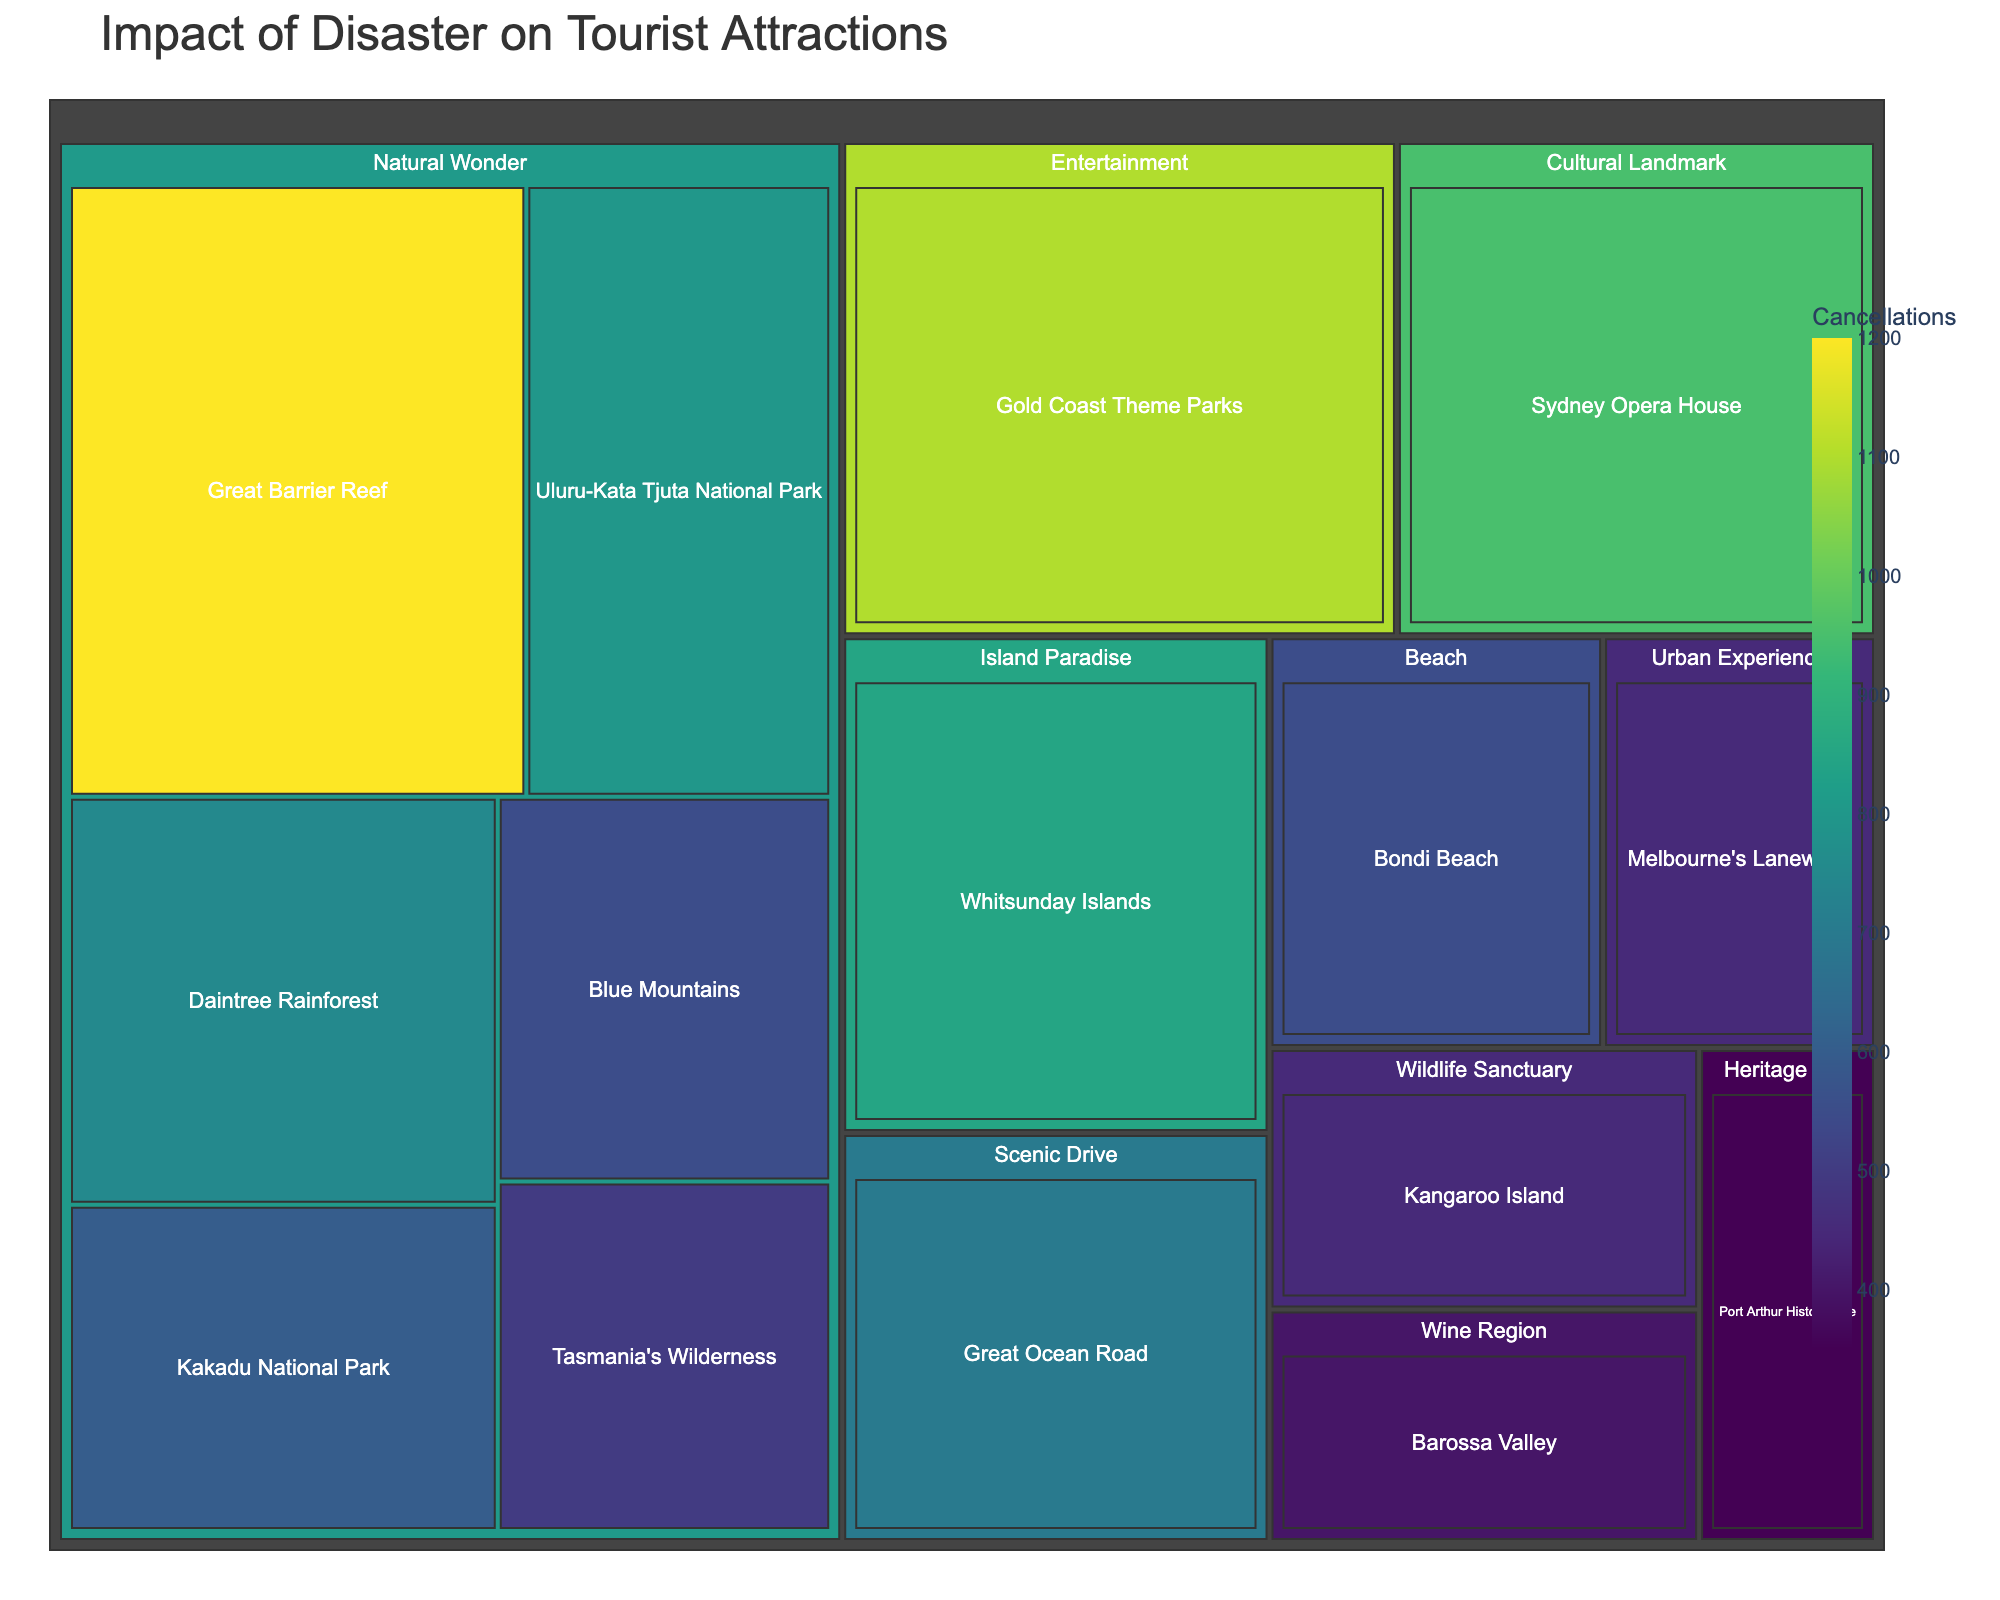What is the total number of cancellations across all tourist attractions? The treemap shows the number of cancellations for each attraction. To find the total, we sum all these values: 1200 + 800 + 950 + 1100 + 600 + 450 + 750 + 550 + 500 + 700 + 400 + 850 + 550 + 450 + 350.
Answer: 10200 Which tourist attraction experienced the highest number of cancellations? The treemap reveals various regions with their corresponding cancellations. The Great Barrier Reef, with 1200 cancellations, has the highest among all the attractions.
Answer: Great Barrier Reef Which category has the highest cumulative number of cancellations? To determine the category with the highest sum, we add up cancellations by category. 'Natural Wonder' with cancellations: 1200 + 800 + 600 + 750 + 500 + 700 + 550 = 5100. Other categories have lower totals.
Answer: Natural Wonder Compare the total cancellations between Natural Wonder and Entertainment categories. From the Natural Wonder category, we total 1200 + 800 + 600 + 750 + 500 + 700 + 550 = 5100. For Entertainment, it's solely 1100. Thus, Natural Wonder has significantly more cancellations.
Answer: Natural Wonder has more Which two attractions have the closest number of cancellations? To find this, look for relatively similar numbers: Bondi Beach (550) and Blue Mountains (550) have identical cancellations.
Answer: Bondi Beach and Blue Mountains What is the average number of cancellations among the Cultural Landmark category? The Cultural Landmark category contains only the Sydney Opera House with 950 cancellations. Summing and averaging this single value results in 950.
Answer: 950 How many cancellations are there in wine-related attractions? The treemap shows one wine-related location, Barossa Valley, with 400 cancellations.
Answer: 400 Considering island-related attractions, how do Whitsunday Islands compare to Kangaroo Island? Whitsunday Islands have 850 cancellations, whereas Kangaroo Island has 450. The Whitsunday Islands thus experienced more cancellations.
Answer: Whitsunday Islands What percentage of total cancellations does the Sydney Opera House contribute? First, sum total cancellations: 10200. The Sydney Opera House has 950 cancellations. Calculating the percentage: (950 / 10200) * 100%.
Answer: 9.31% Which has more cancellations, Urban Experience or Scenic Drive categories? Urban Experience (450) vs. Scenic Drive (700). Scenic Drive has more cancellations.
Answer: Scenic Drive 